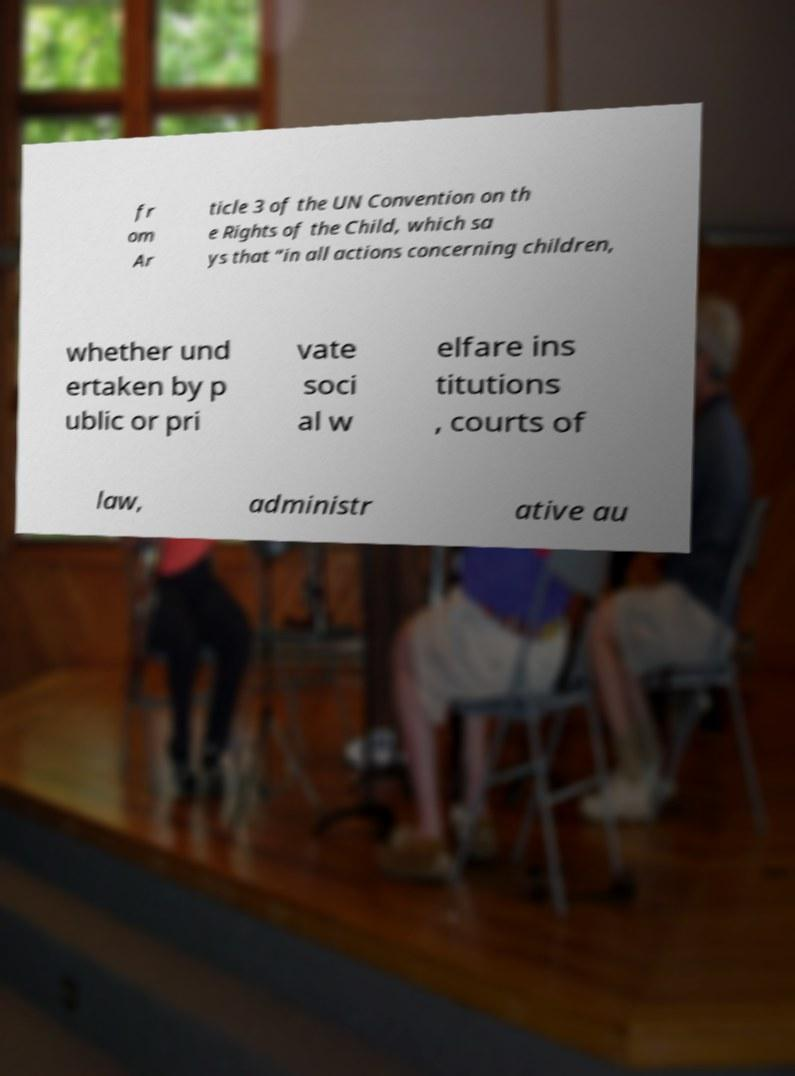For documentation purposes, I need the text within this image transcribed. Could you provide that? fr om Ar ticle 3 of the UN Convention on th e Rights of the Child, which sa ys that “in all actions concerning children, whether und ertaken by p ublic or pri vate soci al w elfare ins titutions , courts of law, administr ative au 